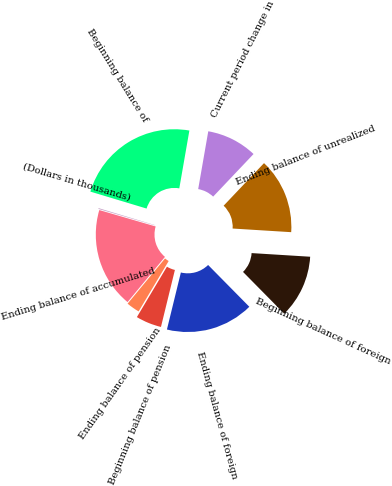Convert chart to OTSL. <chart><loc_0><loc_0><loc_500><loc_500><pie_chart><fcel>(Dollars in thousands)<fcel>Beginning balance of<fcel>Current period change in<fcel>Ending balance of unrealized<fcel>Beginning balance of foreign<fcel>Ending balance of foreign<fcel>Beginning balance of pension<fcel>Ending balance of pension<fcel>Ending balance of accumulated<nl><fcel>0.15%<fcel>23.09%<fcel>9.33%<fcel>13.91%<fcel>11.62%<fcel>16.21%<fcel>4.74%<fcel>2.45%<fcel>18.5%<nl></chart> 